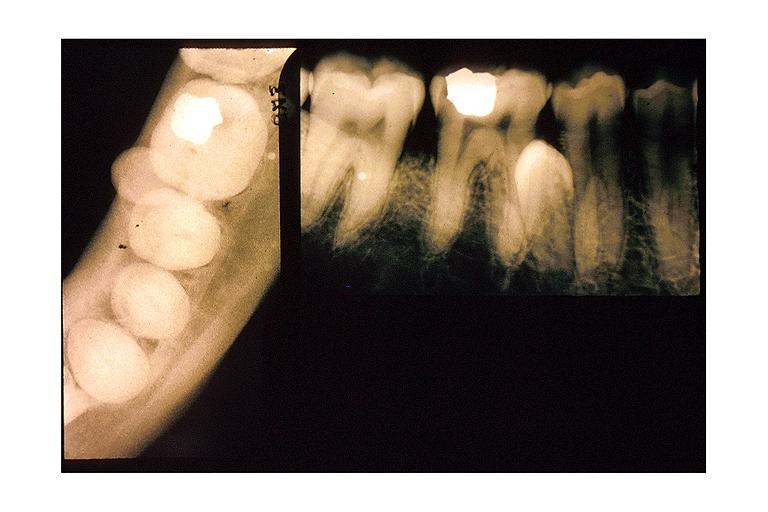does chemical show impacted supernumerary tooth?
Answer the question using a single word or phrase. No 